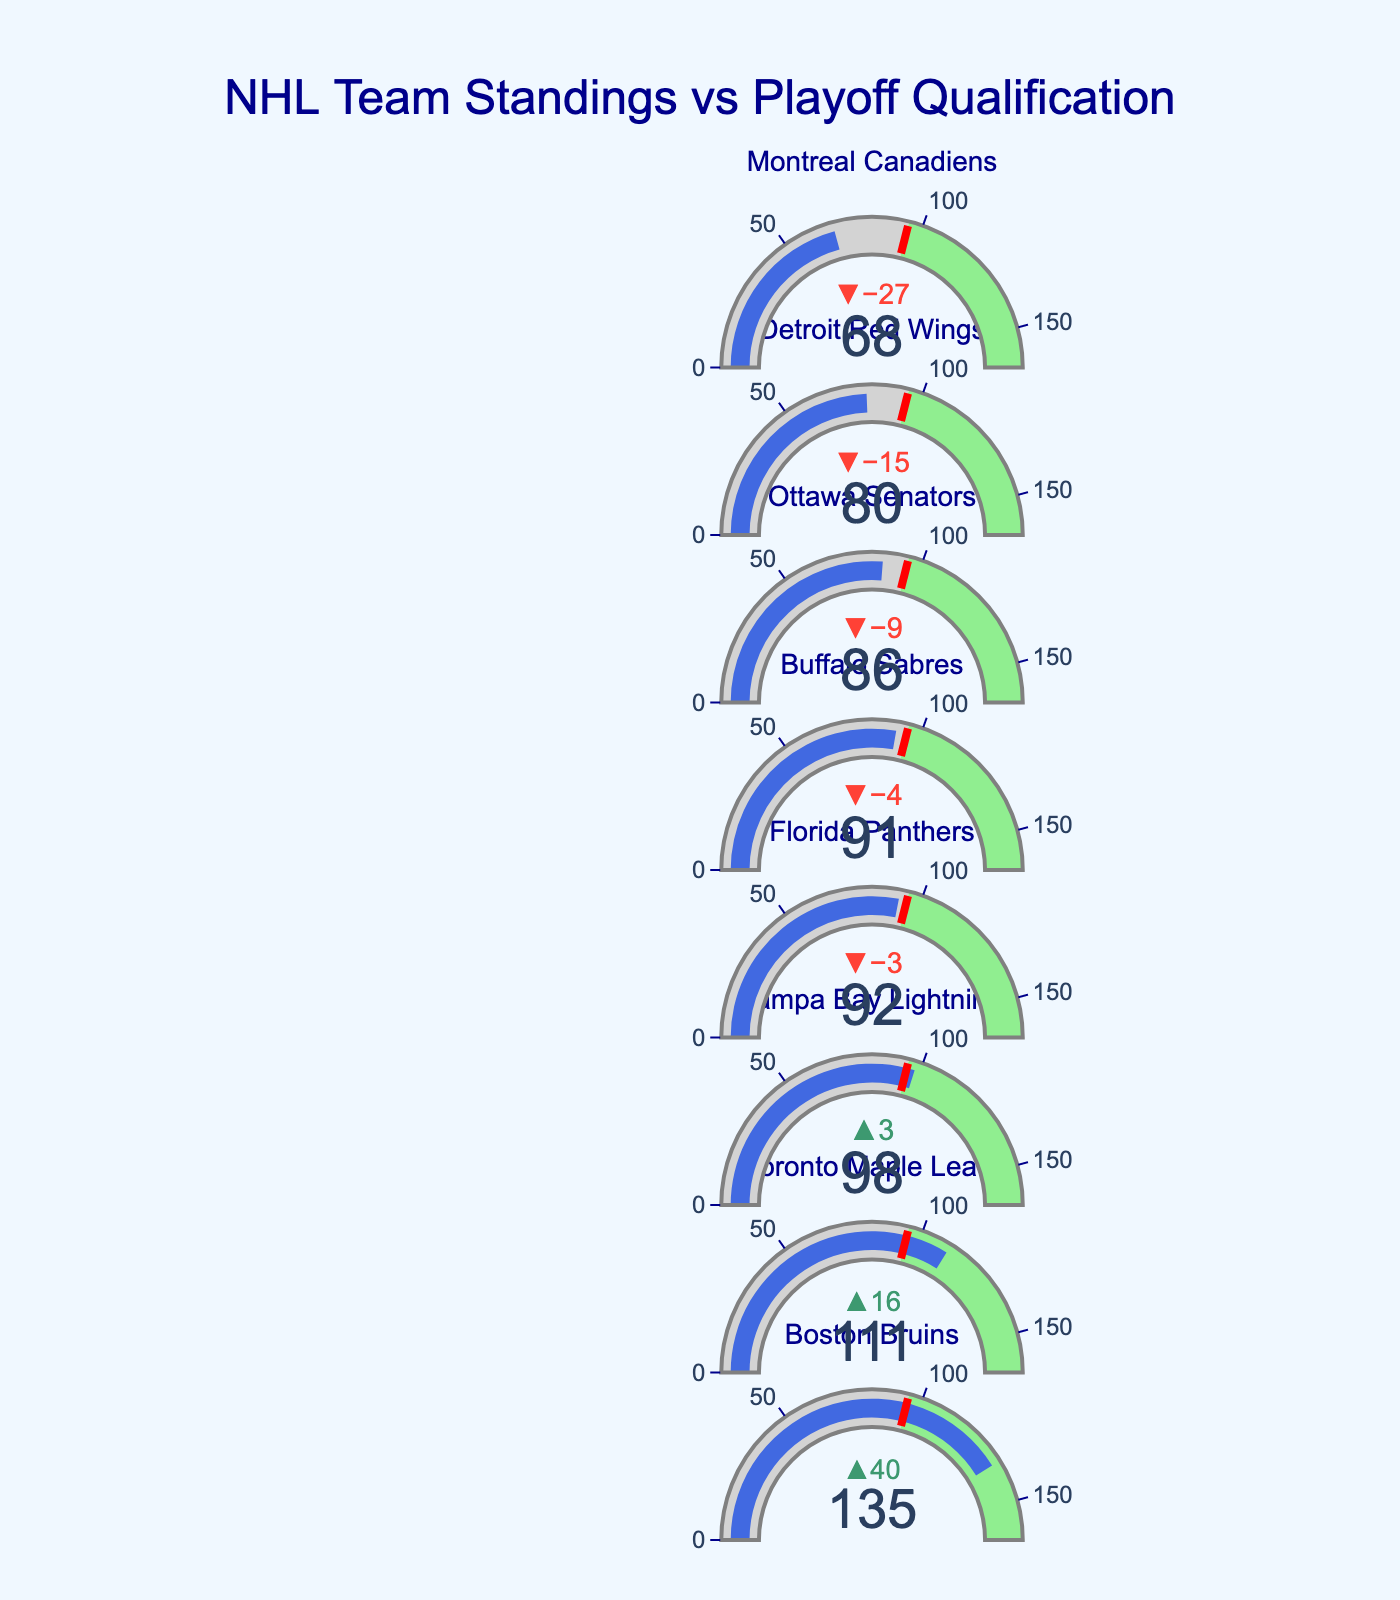Which team has the highest current points? The bullet chart shows each team's current points. By visually inspecting the chart, we see that the Boston Bruins have the highest current points with a value of 135.
Answer: Boston Bruins How far is the Florida Panthers' current point total from the playoff threshold? The chart indicates the current points and the playoff threshold for each team. For the Florida Panthers, the current points are 92, and the playoff threshold is 95. The difference is 95 - 92 = 3.
Answer: 3 points How many teams are currently below the playoff threshold? To determine this, we need to compare each team's current points to the playoff threshold of 95. The teams below the threshold are Florida Panthers (92), Buffalo Sabres (91), Ottawa Senators (86), Detroit Red Wings (80), and Montreal Canadiens (68). Therefore, there are 5 teams below the playoff threshold.
Answer: 5 teams Which teams have already surpassed the playoff qualification threshold? By checking each team’s current points against the playoff threshold (95), the teams that have surpassed the threshold are the Boston Bruins (135 points), the Toronto Maple Leafs (111 points), and the Tampa Bay Lightning (98 points).
Answer: Boston Bruins, Toronto Maple Leafs, Tampa Bay Lightning What is the point difference between the team with the highest and the team with the lowest current points? To calculate this, identify the highest and lowest current points. The Boston Bruins have the highest at 135 points, and the Montreal Canadiens have the lowest at 68 points. The difference is 135 - 68 = 67 points.
Answer: 67 points Which team is closest to the playoff threshold but has not yet reached it? To find the team closest to the threshold without reaching it, we look for the smallest positive difference between the current points and the threshold of 95. The Florida Panthers have 92 points, which is 3 points away from 95, the smallest difference among teams below the threshold.
Answer: Florida Panthers What color is used to indicate the playoff threshold on the gauge? The chart uses color coding to indicate different ranges. The playoff threshold is marked by a red line on the gauge of each team.
Answer: Red How many more points do the Buffalo Sabres need to meet the playoff threshold? The chart shows the current points for the Buffalo Sabres as 91, and the playoff threshold is 95. The difference needed is 95 - 91 = 4 points.
Answer: 4 points By how many points did the Boston Bruins exceed the playoff threshold? The Boston Bruins have 135 points, and the playoff threshold is 95. The difference is 135 - 95 = 40 points.
Answer: 40 points What values define the background color regions on the gauges? Each bullet chart gauge has background color regions indicating different ranges. The area below the playoff threshold (0 to 95 points) is light gray, and the area above the threshold (95 to 164 points) is light green.
Answer: Light gray and Light green 